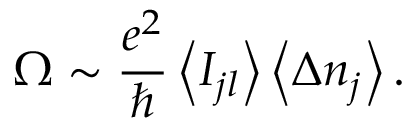<formula> <loc_0><loc_0><loc_500><loc_500>\Omega \sim \frac { e ^ { 2 } } { } \left \langle I _ { j l } \right \rangle \left \langle \Delta n _ { j } \right \rangle .</formula> 